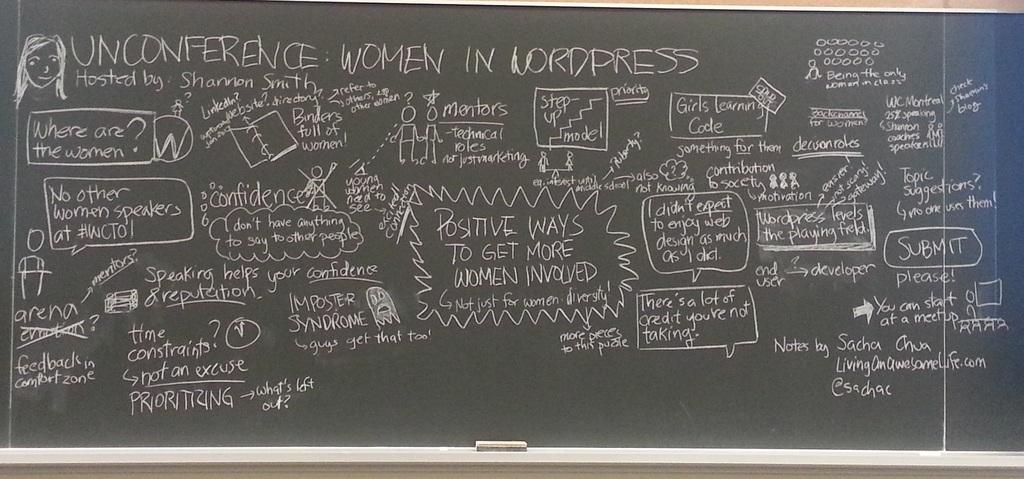<image>
Share a concise interpretation of the image provided. A chalkboard with many things written the biggest thing reads UNCONFERENCE IN LORDPRESS. 